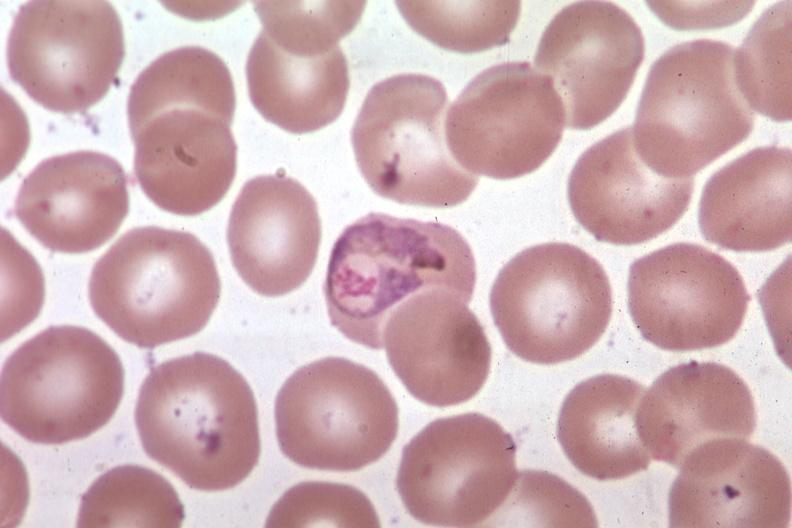does vessel show oil wrights excellent?
Answer the question using a single word or phrase. No 